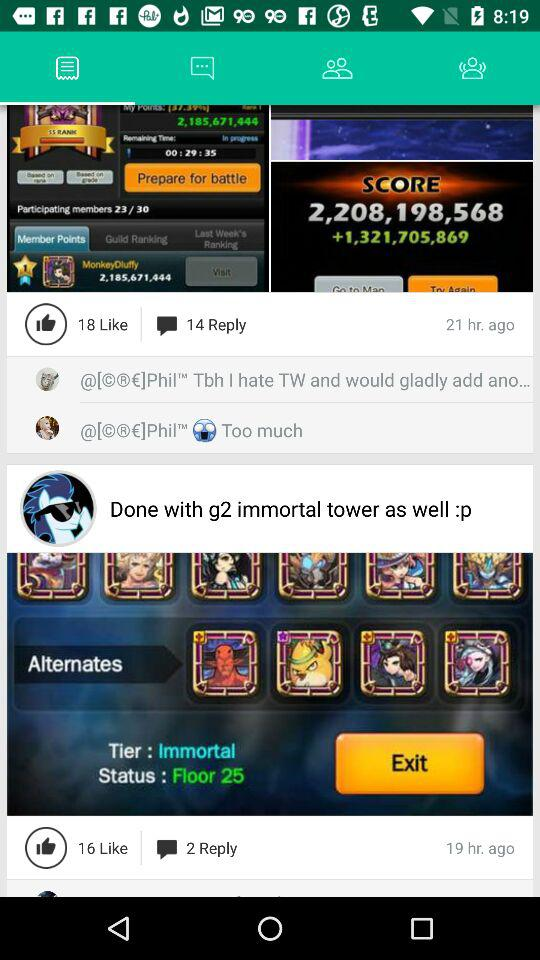What is the number of the maximum comments?
When the provided information is insufficient, respond with <no answer>. <no answer> 